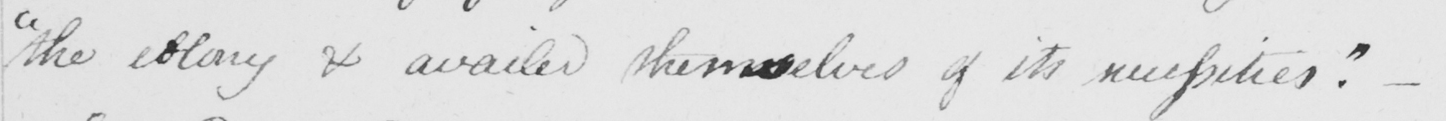Can you tell me what this handwritten text says? " the colony and availed themselves of its necessities . "   _ 